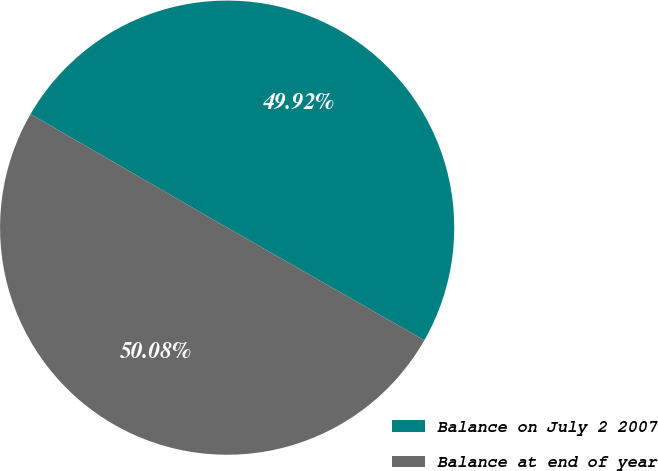Convert chart. <chart><loc_0><loc_0><loc_500><loc_500><pie_chart><fcel>Balance on July 2 2007<fcel>Balance at end of year<nl><fcel>49.92%<fcel>50.08%<nl></chart> 